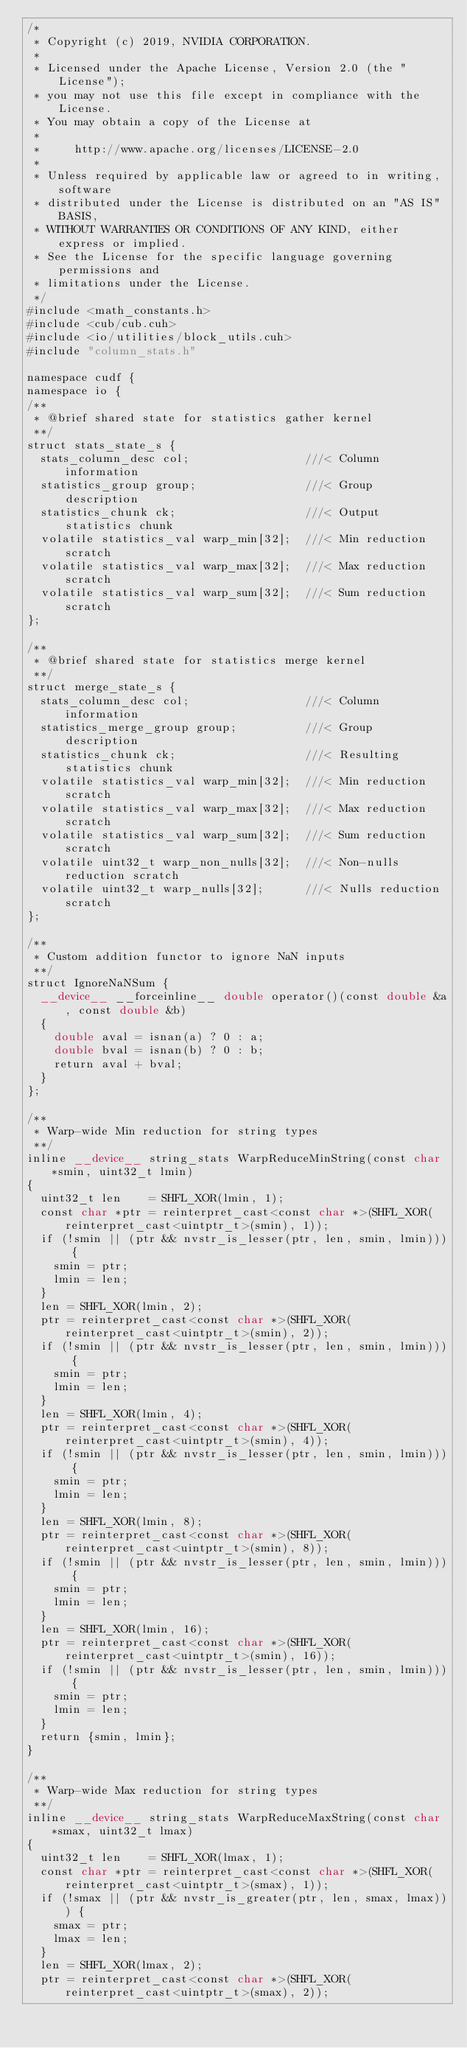<code> <loc_0><loc_0><loc_500><loc_500><_Cuda_>/*
 * Copyright (c) 2019, NVIDIA CORPORATION.
 *
 * Licensed under the Apache License, Version 2.0 (the "License");
 * you may not use this file except in compliance with the License.
 * You may obtain a copy of the License at
 *
 *     http://www.apache.org/licenses/LICENSE-2.0
 *
 * Unless required by applicable law or agreed to in writing, software
 * distributed under the License is distributed on an "AS IS" BASIS,
 * WITHOUT WARRANTIES OR CONDITIONS OF ANY KIND, either express or implied.
 * See the License for the specific language governing permissions and
 * limitations under the License.
 */
#include <math_constants.h>
#include <cub/cub.cuh>
#include <io/utilities/block_utils.cuh>
#include "column_stats.h"

namespace cudf {
namespace io {
/**
 * @brief shared state for statistics gather kernel
 **/
struct stats_state_s {
  stats_column_desc col;                 ///< Column information
  statistics_group group;                ///< Group description
  statistics_chunk ck;                   ///< Output statistics chunk
  volatile statistics_val warp_min[32];  ///< Min reduction scratch
  volatile statistics_val warp_max[32];  ///< Max reduction scratch
  volatile statistics_val warp_sum[32];  ///< Sum reduction scratch
};

/**
 * @brief shared state for statistics merge kernel
 **/
struct merge_state_s {
  stats_column_desc col;                 ///< Column information
  statistics_merge_group group;          ///< Group description
  statistics_chunk ck;                   ///< Resulting statistics chunk
  volatile statistics_val warp_min[32];  ///< Min reduction scratch
  volatile statistics_val warp_max[32];  ///< Max reduction scratch
  volatile statistics_val warp_sum[32];  ///< Sum reduction scratch
  volatile uint32_t warp_non_nulls[32];  ///< Non-nulls reduction scratch
  volatile uint32_t warp_nulls[32];      ///< Nulls reduction scratch
};

/**
 * Custom addition functor to ignore NaN inputs
 **/
struct IgnoreNaNSum {
  __device__ __forceinline__ double operator()(const double &a, const double &b)
  {
    double aval = isnan(a) ? 0 : a;
    double bval = isnan(b) ? 0 : b;
    return aval + bval;
  }
};

/**
 * Warp-wide Min reduction for string types
 **/
inline __device__ string_stats WarpReduceMinString(const char *smin, uint32_t lmin)
{
  uint32_t len    = SHFL_XOR(lmin, 1);
  const char *ptr = reinterpret_cast<const char *>(SHFL_XOR(reinterpret_cast<uintptr_t>(smin), 1));
  if (!smin || (ptr && nvstr_is_lesser(ptr, len, smin, lmin))) {
    smin = ptr;
    lmin = len;
  }
  len = SHFL_XOR(lmin, 2);
  ptr = reinterpret_cast<const char *>(SHFL_XOR(reinterpret_cast<uintptr_t>(smin), 2));
  if (!smin || (ptr && nvstr_is_lesser(ptr, len, smin, lmin))) {
    smin = ptr;
    lmin = len;
  }
  len = SHFL_XOR(lmin, 4);
  ptr = reinterpret_cast<const char *>(SHFL_XOR(reinterpret_cast<uintptr_t>(smin), 4));
  if (!smin || (ptr && nvstr_is_lesser(ptr, len, smin, lmin))) {
    smin = ptr;
    lmin = len;
  }
  len = SHFL_XOR(lmin, 8);
  ptr = reinterpret_cast<const char *>(SHFL_XOR(reinterpret_cast<uintptr_t>(smin), 8));
  if (!smin || (ptr && nvstr_is_lesser(ptr, len, smin, lmin))) {
    smin = ptr;
    lmin = len;
  }
  len = SHFL_XOR(lmin, 16);
  ptr = reinterpret_cast<const char *>(SHFL_XOR(reinterpret_cast<uintptr_t>(smin), 16));
  if (!smin || (ptr && nvstr_is_lesser(ptr, len, smin, lmin))) {
    smin = ptr;
    lmin = len;
  }
  return {smin, lmin};
}

/**
 * Warp-wide Max reduction for string types
 **/
inline __device__ string_stats WarpReduceMaxString(const char *smax, uint32_t lmax)
{
  uint32_t len    = SHFL_XOR(lmax, 1);
  const char *ptr = reinterpret_cast<const char *>(SHFL_XOR(reinterpret_cast<uintptr_t>(smax), 1));
  if (!smax || (ptr && nvstr_is_greater(ptr, len, smax, lmax))) {
    smax = ptr;
    lmax = len;
  }
  len = SHFL_XOR(lmax, 2);
  ptr = reinterpret_cast<const char *>(SHFL_XOR(reinterpret_cast<uintptr_t>(smax), 2));</code> 